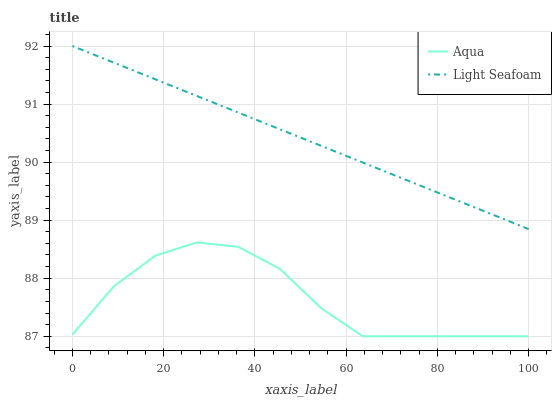Does Aqua have the minimum area under the curve?
Answer yes or no. Yes. Does Light Seafoam have the maximum area under the curve?
Answer yes or no. Yes. Does Aqua have the maximum area under the curve?
Answer yes or no. No. Is Light Seafoam the smoothest?
Answer yes or no. Yes. Is Aqua the roughest?
Answer yes or no. Yes. Is Aqua the smoothest?
Answer yes or no. No. Does Aqua have the lowest value?
Answer yes or no. Yes. Does Light Seafoam have the highest value?
Answer yes or no. Yes. Does Aqua have the highest value?
Answer yes or no. No. Is Aqua less than Light Seafoam?
Answer yes or no. Yes. Is Light Seafoam greater than Aqua?
Answer yes or no. Yes. Does Aqua intersect Light Seafoam?
Answer yes or no. No. 